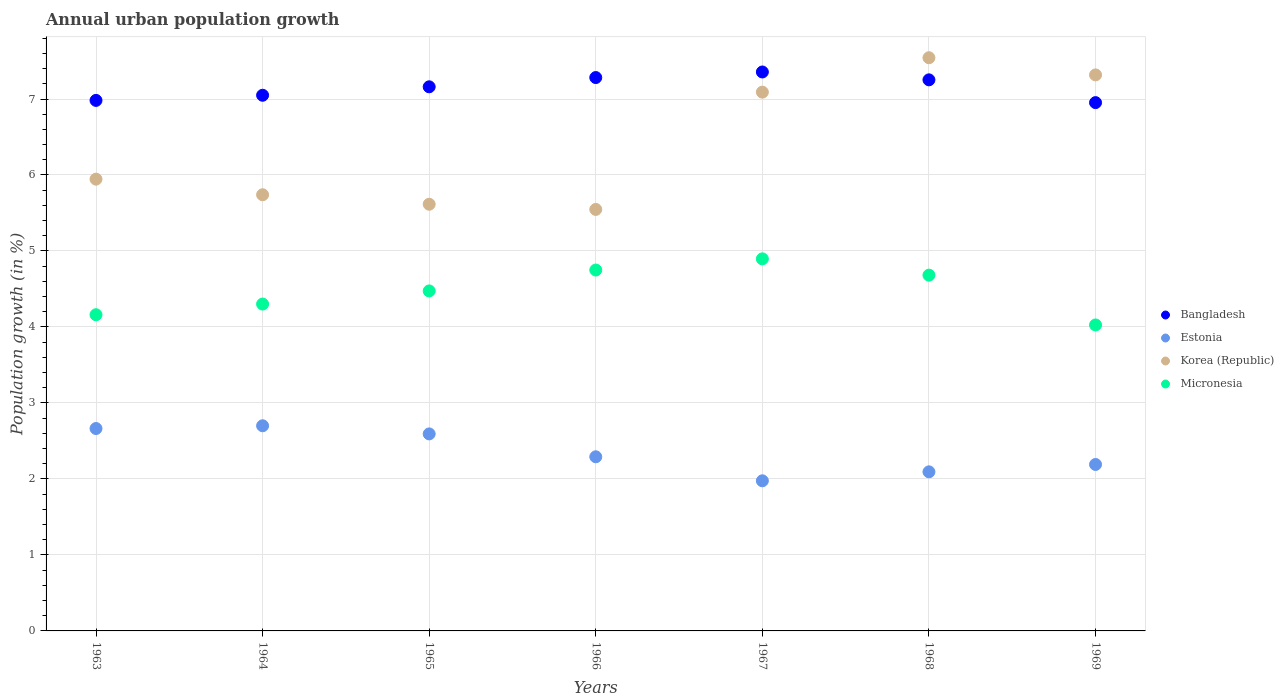How many different coloured dotlines are there?
Ensure brevity in your answer.  4. Is the number of dotlines equal to the number of legend labels?
Provide a succinct answer. Yes. What is the percentage of urban population growth in Korea (Republic) in 1969?
Your answer should be compact. 7.32. Across all years, what is the maximum percentage of urban population growth in Estonia?
Provide a short and direct response. 2.7. Across all years, what is the minimum percentage of urban population growth in Micronesia?
Offer a very short reply. 4.03. In which year was the percentage of urban population growth in Bangladesh maximum?
Offer a terse response. 1967. In which year was the percentage of urban population growth in Bangladesh minimum?
Offer a terse response. 1969. What is the total percentage of urban population growth in Micronesia in the graph?
Offer a terse response. 31.29. What is the difference between the percentage of urban population growth in Bangladesh in 1964 and that in 1969?
Provide a short and direct response. 0.1. What is the difference between the percentage of urban population growth in Micronesia in 1967 and the percentage of urban population growth in Estonia in 1965?
Offer a very short reply. 2.3. What is the average percentage of urban population growth in Micronesia per year?
Keep it short and to the point. 4.47. In the year 1966, what is the difference between the percentage of urban population growth in Korea (Republic) and percentage of urban population growth in Micronesia?
Your answer should be compact. 0.8. What is the ratio of the percentage of urban population growth in Micronesia in 1965 to that in 1967?
Offer a terse response. 0.91. Is the percentage of urban population growth in Micronesia in 1963 less than that in 1969?
Offer a terse response. No. Is the difference between the percentage of urban population growth in Korea (Republic) in 1964 and 1969 greater than the difference between the percentage of urban population growth in Micronesia in 1964 and 1969?
Make the answer very short. No. What is the difference between the highest and the second highest percentage of urban population growth in Estonia?
Provide a succinct answer. 0.04. What is the difference between the highest and the lowest percentage of urban population growth in Bangladesh?
Offer a terse response. 0.4. Is the sum of the percentage of urban population growth in Bangladesh in 1963 and 1967 greater than the maximum percentage of urban population growth in Korea (Republic) across all years?
Give a very brief answer. Yes. Is it the case that in every year, the sum of the percentage of urban population growth in Estonia and percentage of urban population growth in Bangladesh  is greater than the sum of percentage of urban population growth in Korea (Republic) and percentage of urban population growth in Micronesia?
Your answer should be compact. Yes. Is it the case that in every year, the sum of the percentage of urban population growth in Bangladesh and percentage of urban population growth in Micronesia  is greater than the percentage of urban population growth in Estonia?
Provide a short and direct response. Yes. Is the percentage of urban population growth in Estonia strictly greater than the percentage of urban population growth in Bangladesh over the years?
Give a very brief answer. No. What is the difference between two consecutive major ticks on the Y-axis?
Offer a very short reply. 1. Does the graph contain any zero values?
Provide a succinct answer. No. Does the graph contain grids?
Offer a very short reply. Yes. Where does the legend appear in the graph?
Provide a short and direct response. Center right. How many legend labels are there?
Your answer should be very brief. 4. What is the title of the graph?
Ensure brevity in your answer.  Annual urban population growth. Does "Haiti" appear as one of the legend labels in the graph?
Make the answer very short. No. What is the label or title of the X-axis?
Give a very brief answer. Years. What is the label or title of the Y-axis?
Offer a terse response. Population growth (in %). What is the Population growth (in %) of Bangladesh in 1963?
Provide a short and direct response. 6.98. What is the Population growth (in %) of Estonia in 1963?
Provide a succinct answer. 2.66. What is the Population growth (in %) in Korea (Republic) in 1963?
Ensure brevity in your answer.  5.95. What is the Population growth (in %) in Micronesia in 1963?
Your answer should be very brief. 4.16. What is the Population growth (in %) of Bangladesh in 1964?
Make the answer very short. 7.05. What is the Population growth (in %) in Estonia in 1964?
Give a very brief answer. 2.7. What is the Population growth (in %) of Korea (Republic) in 1964?
Keep it short and to the point. 5.74. What is the Population growth (in %) of Micronesia in 1964?
Your answer should be very brief. 4.3. What is the Population growth (in %) in Bangladesh in 1965?
Your answer should be compact. 7.16. What is the Population growth (in %) in Estonia in 1965?
Your response must be concise. 2.59. What is the Population growth (in %) in Korea (Republic) in 1965?
Your response must be concise. 5.62. What is the Population growth (in %) of Micronesia in 1965?
Ensure brevity in your answer.  4.47. What is the Population growth (in %) in Bangladesh in 1966?
Provide a short and direct response. 7.28. What is the Population growth (in %) of Estonia in 1966?
Your response must be concise. 2.29. What is the Population growth (in %) in Korea (Republic) in 1966?
Provide a short and direct response. 5.55. What is the Population growth (in %) of Micronesia in 1966?
Provide a succinct answer. 4.75. What is the Population growth (in %) of Bangladesh in 1967?
Your answer should be compact. 7.36. What is the Population growth (in %) in Estonia in 1967?
Your answer should be very brief. 1.98. What is the Population growth (in %) of Korea (Republic) in 1967?
Offer a terse response. 7.09. What is the Population growth (in %) of Micronesia in 1967?
Your answer should be very brief. 4.9. What is the Population growth (in %) of Bangladesh in 1968?
Ensure brevity in your answer.  7.25. What is the Population growth (in %) in Estonia in 1968?
Offer a terse response. 2.09. What is the Population growth (in %) in Korea (Republic) in 1968?
Ensure brevity in your answer.  7.54. What is the Population growth (in %) in Micronesia in 1968?
Make the answer very short. 4.68. What is the Population growth (in %) of Bangladesh in 1969?
Offer a terse response. 6.95. What is the Population growth (in %) in Estonia in 1969?
Your answer should be very brief. 2.19. What is the Population growth (in %) in Korea (Republic) in 1969?
Ensure brevity in your answer.  7.32. What is the Population growth (in %) of Micronesia in 1969?
Offer a very short reply. 4.03. Across all years, what is the maximum Population growth (in %) of Bangladesh?
Offer a very short reply. 7.36. Across all years, what is the maximum Population growth (in %) in Estonia?
Make the answer very short. 2.7. Across all years, what is the maximum Population growth (in %) in Korea (Republic)?
Give a very brief answer. 7.54. Across all years, what is the maximum Population growth (in %) of Micronesia?
Your answer should be very brief. 4.9. Across all years, what is the minimum Population growth (in %) in Bangladesh?
Provide a succinct answer. 6.95. Across all years, what is the minimum Population growth (in %) in Estonia?
Provide a succinct answer. 1.98. Across all years, what is the minimum Population growth (in %) of Korea (Republic)?
Provide a succinct answer. 5.55. Across all years, what is the minimum Population growth (in %) in Micronesia?
Provide a short and direct response. 4.03. What is the total Population growth (in %) in Bangladesh in the graph?
Your answer should be very brief. 50.03. What is the total Population growth (in %) of Estonia in the graph?
Your answer should be compact. 16.51. What is the total Population growth (in %) in Korea (Republic) in the graph?
Your answer should be compact. 44.8. What is the total Population growth (in %) of Micronesia in the graph?
Make the answer very short. 31.29. What is the difference between the Population growth (in %) in Bangladesh in 1963 and that in 1964?
Your response must be concise. -0.07. What is the difference between the Population growth (in %) of Estonia in 1963 and that in 1964?
Ensure brevity in your answer.  -0.04. What is the difference between the Population growth (in %) in Korea (Republic) in 1963 and that in 1964?
Provide a short and direct response. 0.21. What is the difference between the Population growth (in %) of Micronesia in 1963 and that in 1964?
Ensure brevity in your answer.  -0.14. What is the difference between the Population growth (in %) in Bangladesh in 1963 and that in 1965?
Your answer should be very brief. -0.18. What is the difference between the Population growth (in %) of Estonia in 1963 and that in 1965?
Ensure brevity in your answer.  0.07. What is the difference between the Population growth (in %) in Korea (Republic) in 1963 and that in 1965?
Make the answer very short. 0.33. What is the difference between the Population growth (in %) in Micronesia in 1963 and that in 1965?
Keep it short and to the point. -0.31. What is the difference between the Population growth (in %) in Bangladesh in 1963 and that in 1966?
Offer a terse response. -0.3. What is the difference between the Population growth (in %) in Estonia in 1963 and that in 1966?
Give a very brief answer. 0.37. What is the difference between the Population growth (in %) of Korea (Republic) in 1963 and that in 1966?
Provide a succinct answer. 0.4. What is the difference between the Population growth (in %) in Micronesia in 1963 and that in 1966?
Your response must be concise. -0.59. What is the difference between the Population growth (in %) of Bangladesh in 1963 and that in 1967?
Keep it short and to the point. -0.37. What is the difference between the Population growth (in %) of Estonia in 1963 and that in 1967?
Offer a very short reply. 0.69. What is the difference between the Population growth (in %) of Korea (Republic) in 1963 and that in 1967?
Ensure brevity in your answer.  -1.14. What is the difference between the Population growth (in %) of Micronesia in 1963 and that in 1967?
Your answer should be compact. -0.74. What is the difference between the Population growth (in %) in Bangladesh in 1963 and that in 1968?
Ensure brevity in your answer.  -0.27. What is the difference between the Population growth (in %) in Estonia in 1963 and that in 1968?
Keep it short and to the point. 0.57. What is the difference between the Population growth (in %) of Korea (Republic) in 1963 and that in 1968?
Your response must be concise. -1.6. What is the difference between the Population growth (in %) in Micronesia in 1963 and that in 1968?
Your answer should be very brief. -0.52. What is the difference between the Population growth (in %) of Bangladesh in 1963 and that in 1969?
Give a very brief answer. 0.03. What is the difference between the Population growth (in %) of Estonia in 1963 and that in 1969?
Give a very brief answer. 0.47. What is the difference between the Population growth (in %) in Korea (Republic) in 1963 and that in 1969?
Provide a short and direct response. -1.37. What is the difference between the Population growth (in %) of Micronesia in 1963 and that in 1969?
Your response must be concise. 0.13. What is the difference between the Population growth (in %) of Bangladesh in 1964 and that in 1965?
Keep it short and to the point. -0.11. What is the difference between the Population growth (in %) of Estonia in 1964 and that in 1965?
Your response must be concise. 0.11. What is the difference between the Population growth (in %) in Korea (Republic) in 1964 and that in 1965?
Offer a terse response. 0.12. What is the difference between the Population growth (in %) of Micronesia in 1964 and that in 1965?
Provide a succinct answer. -0.17. What is the difference between the Population growth (in %) in Bangladesh in 1964 and that in 1966?
Offer a very short reply. -0.23. What is the difference between the Population growth (in %) of Estonia in 1964 and that in 1966?
Your response must be concise. 0.41. What is the difference between the Population growth (in %) in Korea (Republic) in 1964 and that in 1966?
Provide a short and direct response. 0.19. What is the difference between the Population growth (in %) of Micronesia in 1964 and that in 1966?
Your answer should be very brief. -0.45. What is the difference between the Population growth (in %) of Bangladesh in 1964 and that in 1967?
Make the answer very short. -0.31. What is the difference between the Population growth (in %) in Estonia in 1964 and that in 1967?
Keep it short and to the point. 0.72. What is the difference between the Population growth (in %) of Korea (Republic) in 1964 and that in 1967?
Your answer should be very brief. -1.35. What is the difference between the Population growth (in %) in Micronesia in 1964 and that in 1967?
Your answer should be compact. -0.59. What is the difference between the Population growth (in %) of Bangladesh in 1964 and that in 1968?
Make the answer very short. -0.2. What is the difference between the Population growth (in %) of Estonia in 1964 and that in 1968?
Keep it short and to the point. 0.61. What is the difference between the Population growth (in %) of Korea (Republic) in 1964 and that in 1968?
Offer a very short reply. -1.8. What is the difference between the Population growth (in %) of Micronesia in 1964 and that in 1968?
Ensure brevity in your answer.  -0.38. What is the difference between the Population growth (in %) in Bangladesh in 1964 and that in 1969?
Your response must be concise. 0.1. What is the difference between the Population growth (in %) of Estonia in 1964 and that in 1969?
Your answer should be compact. 0.51. What is the difference between the Population growth (in %) of Korea (Republic) in 1964 and that in 1969?
Your answer should be very brief. -1.58. What is the difference between the Population growth (in %) of Micronesia in 1964 and that in 1969?
Your response must be concise. 0.27. What is the difference between the Population growth (in %) of Bangladesh in 1965 and that in 1966?
Provide a short and direct response. -0.12. What is the difference between the Population growth (in %) in Estonia in 1965 and that in 1966?
Your response must be concise. 0.3. What is the difference between the Population growth (in %) of Korea (Republic) in 1965 and that in 1966?
Offer a very short reply. 0.07. What is the difference between the Population growth (in %) of Micronesia in 1965 and that in 1966?
Ensure brevity in your answer.  -0.27. What is the difference between the Population growth (in %) in Bangladesh in 1965 and that in 1967?
Your answer should be very brief. -0.2. What is the difference between the Population growth (in %) in Estonia in 1965 and that in 1967?
Provide a short and direct response. 0.62. What is the difference between the Population growth (in %) in Korea (Republic) in 1965 and that in 1967?
Ensure brevity in your answer.  -1.48. What is the difference between the Population growth (in %) in Micronesia in 1965 and that in 1967?
Make the answer very short. -0.42. What is the difference between the Population growth (in %) in Bangladesh in 1965 and that in 1968?
Offer a terse response. -0.09. What is the difference between the Population growth (in %) of Estonia in 1965 and that in 1968?
Provide a succinct answer. 0.5. What is the difference between the Population growth (in %) in Korea (Republic) in 1965 and that in 1968?
Provide a succinct answer. -1.93. What is the difference between the Population growth (in %) in Micronesia in 1965 and that in 1968?
Give a very brief answer. -0.21. What is the difference between the Population growth (in %) of Bangladesh in 1965 and that in 1969?
Give a very brief answer. 0.21. What is the difference between the Population growth (in %) of Estonia in 1965 and that in 1969?
Your answer should be compact. 0.4. What is the difference between the Population growth (in %) of Korea (Republic) in 1965 and that in 1969?
Make the answer very short. -1.7. What is the difference between the Population growth (in %) of Micronesia in 1965 and that in 1969?
Your answer should be compact. 0.45. What is the difference between the Population growth (in %) of Bangladesh in 1966 and that in 1967?
Keep it short and to the point. -0.07. What is the difference between the Population growth (in %) in Estonia in 1966 and that in 1967?
Offer a very short reply. 0.32. What is the difference between the Population growth (in %) of Korea (Republic) in 1966 and that in 1967?
Give a very brief answer. -1.54. What is the difference between the Population growth (in %) in Micronesia in 1966 and that in 1967?
Your answer should be very brief. -0.15. What is the difference between the Population growth (in %) in Bangladesh in 1966 and that in 1968?
Your response must be concise. 0.03. What is the difference between the Population growth (in %) in Estonia in 1966 and that in 1968?
Offer a terse response. 0.2. What is the difference between the Population growth (in %) of Korea (Republic) in 1966 and that in 1968?
Provide a short and direct response. -2. What is the difference between the Population growth (in %) of Micronesia in 1966 and that in 1968?
Give a very brief answer. 0.07. What is the difference between the Population growth (in %) of Bangladesh in 1966 and that in 1969?
Keep it short and to the point. 0.33. What is the difference between the Population growth (in %) in Estonia in 1966 and that in 1969?
Make the answer very short. 0.1. What is the difference between the Population growth (in %) in Korea (Republic) in 1966 and that in 1969?
Make the answer very short. -1.77. What is the difference between the Population growth (in %) of Micronesia in 1966 and that in 1969?
Your answer should be very brief. 0.72. What is the difference between the Population growth (in %) of Bangladesh in 1967 and that in 1968?
Your response must be concise. 0.1. What is the difference between the Population growth (in %) of Estonia in 1967 and that in 1968?
Ensure brevity in your answer.  -0.12. What is the difference between the Population growth (in %) of Korea (Republic) in 1967 and that in 1968?
Offer a very short reply. -0.45. What is the difference between the Population growth (in %) of Micronesia in 1967 and that in 1968?
Provide a short and direct response. 0.21. What is the difference between the Population growth (in %) of Bangladesh in 1967 and that in 1969?
Provide a short and direct response. 0.4. What is the difference between the Population growth (in %) of Estonia in 1967 and that in 1969?
Give a very brief answer. -0.21. What is the difference between the Population growth (in %) in Korea (Republic) in 1967 and that in 1969?
Ensure brevity in your answer.  -0.23. What is the difference between the Population growth (in %) of Micronesia in 1967 and that in 1969?
Provide a short and direct response. 0.87. What is the difference between the Population growth (in %) in Bangladesh in 1968 and that in 1969?
Make the answer very short. 0.3. What is the difference between the Population growth (in %) of Estonia in 1968 and that in 1969?
Keep it short and to the point. -0.1. What is the difference between the Population growth (in %) of Korea (Republic) in 1968 and that in 1969?
Provide a short and direct response. 0.23. What is the difference between the Population growth (in %) of Micronesia in 1968 and that in 1969?
Your response must be concise. 0.66. What is the difference between the Population growth (in %) of Bangladesh in 1963 and the Population growth (in %) of Estonia in 1964?
Offer a terse response. 4.28. What is the difference between the Population growth (in %) of Bangladesh in 1963 and the Population growth (in %) of Korea (Republic) in 1964?
Your answer should be compact. 1.24. What is the difference between the Population growth (in %) of Bangladesh in 1963 and the Population growth (in %) of Micronesia in 1964?
Ensure brevity in your answer.  2.68. What is the difference between the Population growth (in %) in Estonia in 1963 and the Population growth (in %) in Korea (Republic) in 1964?
Keep it short and to the point. -3.08. What is the difference between the Population growth (in %) in Estonia in 1963 and the Population growth (in %) in Micronesia in 1964?
Your response must be concise. -1.64. What is the difference between the Population growth (in %) of Korea (Republic) in 1963 and the Population growth (in %) of Micronesia in 1964?
Offer a very short reply. 1.64. What is the difference between the Population growth (in %) in Bangladesh in 1963 and the Population growth (in %) in Estonia in 1965?
Keep it short and to the point. 4.39. What is the difference between the Population growth (in %) of Bangladesh in 1963 and the Population growth (in %) of Korea (Republic) in 1965?
Offer a terse response. 1.37. What is the difference between the Population growth (in %) of Bangladesh in 1963 and the Population growth (in %) of Micronesia in 1965?
Your answer should be very brief. 2.51. What is the difference between the Population growth (in %) of Estonia in 1963 and the Population growth (in %) of Korea (Republic) in 1965?
Provide a succinct answer. -2.95. What is the difference between the Population growth (in %) of Estonia in 1963 and the Population growth (in %) of Micronesia in 1965?
Your response must be concise. -1.81. What is the difference between the Population growth (in %) in Korea (Republic) in 1963 and the Population growth (in %) in Micronesia in 1965?
Make the answer very short. 1.47. What is the difference between the Population growth (in %) in Bangladesh in 1963 and the Population growth (in %) in Estonia in 1966?
Keep it short and to the point. 4.69. What is the difference between the Population growth (in %) of Bangladesh in 1963 and the Population growth (in %) of Korea (Republic) in 1966?
Offer a terse response. 1.43. What is the difference between the Population growth (in %) of Bangladesh in 1963 and the Population growth (in %) of Micronesia in 1966?
Your answer should be very brief. 2.23. What is the difference between the Population growth (in %) in Estonia in 1963 and the Population growth (in %) in Korea (Republic) in 1966?
Offer a terse response. -2.88. What is the difference between the Population growth (in %) of Estonia in 1963 and the Population growth (in %) of Micronesia in 1966?
Provide a short and direct response. -2.09. What is the difference between the Population growth (in %) in Korea (Republic) in 1963 and the Population growth (in %) in Micronesia in 1966?
Keep it short and to the point. 1.2. What is the difference between the Population growth (in %) of Bangladesh in 1963 and the Population growth (in %) of Estonia in 1967?
Your answer should be very brief. 5.01. What is the difference between the Population growth (in %) in Bangladesh in 1963 and the Population growth (in %) in Korea (Republic) in 1967?
Your response must be concise. -0.11. What is the difference between the Population growth (in %) in Bangladesh in 1963 and the Population growth (in %) in Micronesia in 1967?
Provide a succinct answer. 2.09. What is the difference between the Population growth (in %) in Estonia in 1963 and the Population growth (in %) in Korea (Republic) in 1967?
Your answer should be compact. -4.43. What is the difference between the Population growth (in %) in Estonia in 1963 and the Population growth (in %) in Micronesia in 1967?
Your response must be concise. -2.23. What is the difference between the Population growth (in %) in Korea (Republic) in 1963 and the Population growth (in %) in Micronesia in 1967?
Your answer should be compact. 1.05. What is the difference between the Population growth (in %) of Bangladesh in 1963 and the Population growth (in %) of Estonia in 1968?
Keep it short and to the point. 4.89. What is the difference between the Population growth (in %) of Bangladesh in 1963 and the Population growth (in %) of Korea (Republic) in 1968?
Offer a terse response. -0.56. What is the difference between the Population growth (in %) in Bangladesh in 1963 and the Population growth (in %) in Micronesia in 1968?
Give a very brief answer. 2.3. What is the difference between the Population growth (in %) of Estonia in 1963 and the Population growth (in %) of Korea (Republic) in 1968?
Ensure brevity in your answer.  -4.88. What is the difference between the Population growth (in %) of Estonia in 1963 and the Population growth (in %) of Micronesia in 1968?
Your answer should be very brief. -2.02. What is the difference between the Population growth (in %) of Korea (Republic) in 1963 and the Population growth (in %) of Micronesia in 1968?
Your answer should be very brief. 1.26. What is the difference between the Population growth (in %) in Bangladesh in 1963 and the Population growth (in %) in Estonia in 1969?
Make the answer very short. 4.79. What is the difference between the Population growth (in %) in Bangladesh in 1963 and the Population growth (in %) in Korea (Republic) in 1969?
Provide a succinct answer. -0.34. What is the difference between the Population growth (in %) in Bangladesh in 1963 and the Population growth (in %) in Micronesia in 1969?
Provide a succinct answer. 2.95. What is the difference between the Population growth (in %) of Estonia in 1963 and the Population growth (in %) of Korea (Republic) in 1969?
Your response must be concise. -4.65. What is the difference between the Population growth (in %) of Estonia in 1963 and the Population growth (in %) of Micronesia in 1969?
Your answer should be very brief. -1.36. What is the difference between the Population growth (in %) in Korea (Republic) in 1963 and the Population growth (in %) in Micronesia in 1969?
Your response must be concise. 1.92. What is the difference between the Population growth (in %) in Bangladesh in 1964 and the Population growth (in %) in Estonia in 1965?
Give a very brief answer. 4.46. What is the difference between the Population growth (in %) in Bangladesh in 1964 and the Population growth (in %) in Korea (Republic) in 1965?
Keep it short and to the point. 1.43. What is the difference between the Population growth (in %) in Bangladesh in 1964 and the Population growth (in %) in Micronesia in 1965?
Your answer should be compact. 2.57. What is the difference between the Population growth (in %) in Estonia in 1964 and the Population growth (in %) in Korea (Republic) in 1965?
Provide a short and direct response. -2.92. What is the difference between the Population growth (in %) in Estonia in 1964 and the Population growth (in %) in Micronesia in 1965?
Offer a terse response. -1.77. What is the difference between the Population growth (in %) in Korea (Republic) in 1964 and the Population growth (in %) in Micronesia in 1965?
Provide a short and direct response. 1.27. What is the difference between the Population growth (in %) of Bangladesh in 1964 and the Population growth (in %) of Estonia in 1966?
Offer a very short reply. 4.76. What is the difference between the Population growth (in %) in Bangladesh in 1964 and the Population growth (in %) in Korea (Republic) in 1966?
Ensure brevity in your answer.  1.5. What is the difference between the Population growth (in %) of Bangladesh in 1964 and the Population growth (in %) of Micronesia in 1966?
Ensure brevity in your answer.  2.3. What is the difference between the Population growth (in %) of Estonia in 1964 and the Population growth (in %) of Korea (Republic) in 1966?
Offer a very short reply. -2.85. What is the difference between the Population growth (in %) in Estonia in 1964 and the Population growth (in %) in Micronesia in 1966?
Ensure brevity in your answer.  -2.05. What is the difference between the Population growth (in %) in Korea (Republic) in 1964 and the Population growth (in %) in Micronesia in 1966?
Offer a very short reply. 0.99. What is the difference between the Population growth (in %) in Bangladesh in 1964 and the Population growth (in %) in Estonia in 1967?
Offer a very short reply. 5.07. What is the difference between the Population growth (in %) in Bangladesh in 1964 and the Population growth (in %) in Korea (Republic) in 1967?
Make the answer very short. -0.04. What is the difference between the Population growth (in %) in Bangladesh in 1964 and the Population growth (in %) in Micronesia in 1967?
Keep it short and to the point. 2.15. What is the difference between the Population growth (in %) of Estonia in 1964 and the Population growth (in %) of Korea (Republic) in 1967?
Give a very brief answer. -4.39. What is the difference between the Population growth (in %) of Estonia in 1964 and the Population growth (in %) of Micronesia in 1967?
Provide a short and direct response. -2.2. What is the difference between the Population growth (in %) in Korea (Republic) in 1964 and the Population growth (in %) in Micronesia in 1967?
Give a very brief answer. 0.84. What is the difference between the Population growth (in %) in Bangladesh in 1964 and the Population growth (in %) in Estonia in 1968?
Ensure brevity in your answer.  4.96. What is the difference between the Population growth (in %) in Bangladesh in 1964 and the Population growth (in %) in Korea (Republic) in 1968?
Give a very brief answer. -0.49. What is the difference between the Population growth (in %) in Bangladesh in 1964 and the Population growth (in %) in Micronesia in 1968?
Offer a very short reply. 2.37. What is the difference between the Population growth (in %) in Estonia in 1964 and the Population growth (in %) in Korea (Republic) in 1968?
Your answer should be very brief. -4.84. What is the difference between the Population growth (in %) in Estonia in 1964 and the Population growth (in %) in Micronesia in 1968?
Make the answer very short. -1.98. What is the difference between the Population growth (in %) of Korea (Republic) in 1964 and the Population growth (in %) of Micronesia in 1968?
Provide a short and direct response. 1.06. What is the difference between the Population growth (in %) in Bangladesh in 1964 and the Population growth (in %) in Estonia in 1969?
Offer a terse response. 4.86. What is the difference between the Population growth (in %) in Bangladesh in 1964 and the Population growth (in %) in Korea (Republic) in 1969?
Keep it short and to the point. -0.27. What is the difference between the Population growth (in %) in Bangladesh in 1964 and the Population growth (in %) in Micronesia in 1969?
Provide a short and direct response. 3.02. What is the difference between the Population growth (in %) of Estonia in 1964 and the Population growth (in %) of Korea (Republic) in 1969?
Offer a terse response. -4.62. What is the difference between the Population growth (in %) in Estonia in 1964 and the Population growth (in %) in Micronesia in 1969?
Ensure brevity in your answer.  -1.33. What is the difference between the Population growth (in %) of Korea (Republic) in 1964 and the Population growth (in %) of Micronesia in 1969?
Your answer should be compact. 1.71. What is the difference between the Population growth (in %) in Bangladesh in 1965 and the Population growth (in %) in Estonia in 1966?
Your response must be concise. 4.87. What is the difference between the Population growth (in %) of Bangladesh in 1965 and the Population growth (in %) of Korea (Republic) in 1966?
Ensure brevity in your answer.  1.61. What is the difference between the Population growth (in %) in Bangladesh in 1965 and the Population growth (in %) in Micronesia in 1966?
Your answer should be compact. 2.41. What is the difference between the Population growth (in %) of Estonia in 1965 and the Population growth (in %) of Korea (Republic) in 1966?
Your answer should be very brief. -2.95. What is the difference between the Population growth (in %) of Estonia in 1965 and the Population growth (in %) of Micronesia in 1966?
Your answer should be compact. -2.16. What is the difference between the Population growth (in %) of Korea (Republic) in 1965 and the Population growth (in %) of Micronesia in 1966?
Your response must be concise. 0.87. What is the difference between the Population growth (in %) in Bangladesh in 1965 and the Population growth (in %) in Estonia in 1967?
Ensure brevity in your answer.  5.18. What is the difference between the Population growth (in %) of Bangladesh in 1965 and the Population growth (in %) of Korea (Republic) in 1967?
Keep it short and to the point. 0.07. What is the difference between the Population growth (in %) in Bangladesh in 1965 and the Population growth (in %) in Micronesia in 1967?
Give a very brief answer. 2.26. What is the difference between the Population growth (in %) of Estonia in 1965 and the Population growth (in %) of Korea (Republic) in 1967?
Your answer should be compact. -4.5. What is the difference between the Population growth (in %) of Estonia in 1965 and the Population growth (in %) of Micronesia in 1967?
Make the answer very short. -2.3. What is the difference between the Population growth (in %) in Korea (Republic) in 1965 and the Population growth (in %) in Micronesia in 1967?
Give a very brief answer. 0.72. What is the difference between the Population growth (in %) of Bangladesh in 1965 and the Population growth (in %) of Estonia in 1968?
Provide a succinct answer. 5.07. What is the difference between the Population growth (in %) in Bangladesh in 1965 and the Population growth (in %) in Korea (Republic) in 1968?
Offer a terse response. -0.38. What is the difference between the Population growth (in %) of Bangladesh in 1965 and the Population growth (in %) of Micronesia in 1968?
Offer a terse response. 2.48. What is the difference between the Population growth (in %) in Estonia in 1965 and the Population growth (in %) in Korea (Republic) in 1968?
Keep it short and to the point. -4.95. What is the difference between the Population growth (in %) of Estonia in 1965 and the Population growth (in %) of Micronesia in 1968?
Offer a very short reply. -2.09. What is the difference between the Population growth (in %) of Korea (Republic) in 1965 and the Population growth (in %) of Micronesia in 1968?
Offer a very short reply. 0.93. What is the difference between the Population growth (in %) of Bangladesh in 1965 and the Population growth (in %) of Estonia in 1969?
Offer a very short reply. 4.97. What is the difference between the Population growth (in %) of Bangladesh in 1965 and the Population growth (in %) of Korea (Republic) in 1969?
Keep it short and to the point. -0.16. What is the difference between the Population growth (in %) of Bangladesh in 1965 and the Population growth (in %) of Micronesia in 1969?
Give a very brief answer. 3.13. What is the difference between the Population growth (in %) in Estonia in 1965 and the Population growth (in %) in Korea (Republic) in 1969?
Provide a succinct answer. -4.72. What is the difference between the Population growth (in %) in Estonia in 1965 and the Population growth (in %) in Micronesia in 1969?
Your answer should be very brief. -1.43. What is the difference between the Population growth (in %) of Korea (Republic) in 1965 and the Population growth (in %) of Micronesia in 1969?
Provide a short and direct response. 1.59. What is the difference between the Population growth (in %) of Bangladesh in 1966 and the Population growth (in %) of Estonia in 1967?
Ensure brevity in your answer.  5.31. What is the difference between the Population growth (in %) in Bangladesh in 1966 and the Population growth (in %) in Korea (Republic) in 1967?
Keep it short and to the point. 0.19. What is the difference between the Population growth (in %) of Bangladesh in 1966 and the Population growth (in %) of Micronesia in 1967?
Give a very brief answer. 2.39. What is the difference between the Population growth (in %) of Estonia in 1966 and the Population growth (in %) of Korea (Republic) in 1967?
Your response must be concise. -4.8. What is the difference between the Population growth (in %) of Estonia in 1966 and the Population growth (in %) of Micronesia in 1967?
Your answer should be compact. -2.6. What is the difference between the Population growth (in %) of Korea (Republic) in 1966 and the Population growth (in %) of Micronesia in 1967?
Keep it short and to the point. 0.65. What is the difference between the Population growth (in %) in Bangladesh in 1966 and the Population growth (in %) in Estonia in 1968?
Provide a succinct answer. 5.19. What is the difference between the Population growth (in %) in Bangladesh in 1966 and the Population growth (in %) in Korea (Republic) in 1968?
Your answer should be very brief. -0.26. What is the difference between the Population growth (in %) in Bangladesh in 1966 and the Population growth (in %) in Micronesia in 1968?
Offer a terse response. 2.6. What is the difference between the Population growth (in %) in Estonia in 1966 and the Population growth (in %) in Korea (Republic) in 1968?
Make the answer very short. -5.25. What is the difference between the Population growth (in %) of Estonia in 1966 and the Population growth (in %) of Micronesia in 1968?
Offer a very short reply. -2.39. What is the difference between the Population growth (in %) of Korea (Republic) in 1966 and the Population growth (in %) of Micronesia in 1968?
Your answer should be very brief. 0.86. What is the difference between the Population growth (in %) of Bangladesh in 1966 and the Population growth (in %) of Estonia in 1969?
Make the answer very short. 5.09. What is the difference between the Population growth (in %) in Bangladesh in 1966 and the Population growth (in %) in Korea (Republic) in 1969?
Offer a terse response. -0.04. What is the difference between the Population growth (in %) in Bangladesh in 1966 and the Population growth (in %) in Micronesia in 1969?
Your answer should be compact. 3.26. What is the difference between the Population growth (in %) of Estonia in 1966 and the Population growth (in %) of Korea (Republic) in 1969?
Offer a very short reply. -5.03. What is the difference between the Population growth (in %) of Estonia in 1966 and the Population growth (in %) of Micronesia in 1969?
Provide a succinct answer. -1.74. What is the difference between the Population growth (in %) in Korea (Republic) in 1966 and the Population growth (in %) in Micronesia in 1969?
Your answer should be very brief. 1.52. What is the difference between the Population growth (in %) in Bangladesh in 1967 and the Population growth (in %) in Estonia in 1968?
Provide a succinct answer. 5.26. What is the difference between the Population growth (in %) of Bangladesh in 1967 and the Population growth (in %) of Korea (Republic) in 1968?
Your answer should be very brief. -0.19. What is the difference between the Population growth (in %) of Bangladesh in 1967 and the Population growth (in %) of Micronesia in 1968?
Your answer should be very brief. 2.67. What is the difference between the Population growth (in %) of Estonia in 1967 and the Population growth (in %) of Korea (Republic) in 1968?
Offer a terse response. -5.57. What is the difference between the Population growth (in %) of Estonia in 1967 and the Population growth (in %) of Micronesia in 1968?
Make the answer very short. -2.71. What is the difference between the Population growth (in %) of Korea (Republic) in 1967 and the Population growth (in %) of Micronesia in 1968?
Your answer should be very brief. 2.41. What is the difference between the Population growth (in %) of Bangladesh in 1967 and the Population growth (in %) of Estonia in 1969?
Make the answer very short. 5.17. What is the difference between the Population growth (in %) in Bangladesh in 1967 and the Population growth (in %) in Korea (Republic) in 1969?
Provide a succinct answer. 0.04. What is the difference between the Population growth (in %) in Bangladesh in 1967 and the Population growth (in %) in Micronesia in 1969?
Provide a short and direct response. 3.33. What is the difference between the Population growth (in %) of Estonia in 1967 and the Population growth (in %) of Korea (Republic) in 1969?
Offer a very short reply. -5.34. What is the difference between the Population growth (in %) in Estonia in 1967 and the Population growth (in %) in Micronesia in 1969?
Make the answer very short. -2.05. What is the difference between the Population growth (in %) in Korea (Republic) in 1967 and the Population growth (in %) in Micronesia in 1969?
Your answer should be very brief. 3.06. What is the difference between the Population growth (in %) in Bangladesh in 1968 and the Population growth (in %) in Estonia in 1969?
Provide a short and direct response. 5.06. What is the difference between the Population growth (in %) of Bangladesh in 1968 and the Population growth (in %) of Korea (Republic) in 1969?
Offer a terse response. -0.07. What is the difference between the Population growth (in %) in Bangladesh in 1968 and the Population growth (in %) in Micronesia in 1969?
Provide a succinct answer. 3.23. What is the difference between the Population growth (in %) of Estonia in 1968 and the Population growth (in %) of Korea (Republic) in 1969?
Your answer should be very brief. -5.22. What is the difference between the Population growth (in %) of Estonia in 1968 and the Population growth (in %) of Micronesia in 1969?
Your answer should be very brief. -1.93. What is the difference between the Population growth (in %) of Korea (Republic) in 1968 and the Population growth (in %) of Micronesia in 1969?
Provide a succinct answer. 3.52. What is the average Population growth (in %) of Bangladesh per year?
Ensure brevity in your answer.  7.15. What is the average Population growth (in %) in Estonia per year?
Your answer should be compact. 2.36. What is the average Population growth (in %) in Korea (Republic) per year?
Offer a terse response. 6.4. What is the average Population growth (in %) in Micronesia per year?
Make the answer very short. 4.47. In the year 1963, what is the difference between the Population growth (in %) in Bangladesh and Population growth (in %) in Estonia?
Offer a very short reply. 4.32. In the year 1963, what is the difference between the Population growth (in %) in Bangladesh and Population growth (in %) in Korea (Republic)?
Your response must be concise. 1.04. In the year 1963, what is the difference between the Population growth (in %) in Bangladesh and Population growth (in %) in Micronesia?
Give a very brief answer. 2.82. In the year 1963, what is the difference between the Population growth (in %) in Estonia and Population growth (in %) in Korea (Republic)?
Provide a short and direct response. -3.28. In the year 1963, what is the difference between the Population growth (in %) in Estonia and Population growth (in %) in Micronesia?
Make the answer very short. -1.5. In the year 1963, what is the difference between the Population growth (in %) in Korea (Republic) and Population growth (in %) in Micronesia?
Provide a short and direct response. 1.78. In the year 1964, what is the difference between the Population growth (in %) in Bangladesh and Population growth (in %) in Estonia?
Offer a very short reply. 4.35. In the year 1964, what is the difference between the Population growth (in %) of Bangladesh and Population growth (in %) of Korea (Republic)?
Offer a very short reply. 1.31. In the year 1964, what is the difference between the Population growth (in %) of Bangladesh and Population growth (in %) of Micronesia?
Give a very brief answer. 2.75. In the year 1964, what is the difference between the Population growth (in %) of Estonia and Population growth (in %) of Korea (Republic)?
Provide a short and direct response. -3.04. In the year 1964, what is the difference between the Population growth (in %) in Estonia and Population growth (in %) in Micronesia?
Your response must be concise. -1.6. In the year 1964, what is the difference between the Population growth (in %) of Korea (Republic) and Population growth (in %) of Micronesia?
Provide a succinct answer. 1.44. In the year 1965, what is the difference between the Population growth (in %) of Bangladesh and Population growth (in %) of Estonia?
Your answer should be very brief. 4.57. In the year 1965, what is the difference between the Population growth (in %) of Bangladesh and Population growth (in %) of Korea (Republic)?
Your response must be concise. 1.55. In the year 1965, what is the difference between the Population growth (in %) in Bangladesh and Population growth (in %) in Micronesia?
Offer a terse response. 2.69. In the year 1965, what is the difference between the Population growth (in %) of Estonia and Population growth (in %) of Korea (Republic)?
Offer a very short reply. -3.02. In the year 1965, what is the difference between the Population growth (in %) in Estonia and Population growth (in %) in Micronesia?
Your response must be concise. -1.88. In the year 1965, what is the difference between the Population growth (in %) of Korea (Republic) and Population growth (in %) of Micronesia?
Provide a short and direct response. 1.14. In the year 1966, what is the difference between the Population growth (in %) in Bangladesh and Population growth (in %) in Estonia?
Provide a succinct answer. 4.99. In the year 1966, what is the difference between the Population growth (in %) in Bangladesh and Population growth (in %) in Korea (Republic)?
Give a very brief answer. 1.74. In the year 1966, what is the difference between the Population growth (in %) of Bangladesh and Population growth (in %) of Micronesia?
Provide a short and direct response. 2.53. In the year 1966, what is the difference between the Population growth (in %) of Estonia and Population growth (in %) of Korea (Republic)?
Your response must be concise. -3.26. In the year 1966, what is the difference between the Population growth (in %) of Estonia and Population growth (in %) of Micronesia?
Offer a very short reply. -2.46. In the year 1966, what is the difference between the Population growth (in %) in Korea (Republic) and Population growth (in %) in Micronesia?
Your response must be concise. 0.8. In the year 1967, what is the difference between the Population growth (in %) in Bangladesh and Population growth (in %) in Estonia?
Your answer should be very brief. 5.38. In the year 1967, what is the difference between the Population growth (in %) in Bangladesh and Population growth (in %) in Korea (Republic)?
Provide a short and direct response. 0.27. In the year 1967, what is the difference between the Population growth (in %) in Bangladesh and Population growth (in %) in Micronesia?
Offer a terse response. 2.46. In the year 1967, what is the difference between the Population growth (in %) in Estonia and Population growth (in %) in Korea (Republic)?
Keep it short and to the point. -5.11. In the year 1967, what is the difference between the Population growth (in %) in Estonia and Population growth (in %) in Micronesia?
Offer a terse response. -2.92. In the year 1967, what is the difference between the Population growth (in %) of Korea (Republic) and Population growth (in %) of Micronesia?
Provide a succinct answer. 2.19. In the year 1968, what is the difference between the Population growth (in %) of Bangladesh and Population growth (in %) of Estonia?
Your answer should be very brief. 5.16. In the year 1968, what is the difference between the Population growth (in %) of Bangladesh and Population growth (in %) of Korea (Republic)?
Offer a terse response. -0.29. In the year 1968, what is the difference between the Population growth (in %) in Bangladesh and Population growth (in %) in Micronesia?
Keep it short and to the point. 2.57. In the year 1968, what is the difference between the Population growth (in %) in Estonia and Population growth (in %) in Korea (Republic)?
Offer a terse response. -5.45. In the year 1968, what is the difference between the Population growth (in %) in Estonia and Population growth (in %) in Micronesia?
Your response must be concise. -2.59. In the year 1968, what is the difference between the Population growth (in %) of Korea (Republic) and Population growth (in %) of Micronesia?
Give a very brief answer. 2.86. In the year 1969, what is the difference between the Population growth (in %) of Bangladesh and Population growth (in %) of Estonia?
Provide a succinct answer. 4.76. In the year 1969, what is the difference between the Population growth (in %) in Bangladesh and Population growth (in %) in Korea (Republic)?
Ensure brevity in your answer.  -0.36. In the year 1969, what is the difference between the Population growth (in %) in Bangladesh and Population growth (in %) in Micronesia?
Provide a succinct answer. 2.93. In the year 1969, what is the difference between the Population growth (in %) of Estonia and Population growth (in %) of Korea (Republic)?
Ensure brevity in your answer.  -5.13. In the year 1969, what is the difference between the Population growth (in %) of Estonia and Population growth (in %) of Micronesia?
Your response must be concise. -1.84. In the year 1969, what is the difference between the Population growth (in %) of Korea (Republic) and Population growth (in %) of Micronesia?
Your answer should be compact. 3.29. What is the ratio of the Population growth (in %) in Bangladesh in 1963 to that in 1964?
Ensure brevity in your answer.  0.99. What is the ratio of the Population growth (in %) of Estonia in 1963 to that in 1964?
Ensure brevity in your answer.  0.99. What is the ratio of the Population growth (in %) in Korea (Republic) in 1963 to that in 1964?
Provide a short and direct response. 1.04. What is the ratio of the Population growth (in %) in Micronesia in 1963 to that in 1964?
Make the answer very short. 0.97. What is the ratio of the Population growth (in %) in Bangladesh in 1963 to that in 1965?
Provide a short and direct response. 0.97. What is the ratio of the Population growth (in %) in Estonia in 1963 to that in 1965?
Ensure brevity in your answer.  1.03. What is the ratio of the Population growth (in %) in Korea (Republic) in 1963 to that in 1965?
Your answer should be compact. 1.06. What is the ratio of the Population growth (in %) in Micronesia in 1963 to that in 1965?
Make the answer very short. 0.93. What is the ratio of the Population growth (in %) of Bangladesh in 1963 to that in 1966?
Give a very brief answer. 0.96. What is the ratio of the Population growth (in %) of Estonia in 1963 to that in 1966?
Ensure brevity in your answer.  1.16. What is the ratio of the Population growth (in %) in Korea (Republic) in 1963 to that in 1966?
Provide a succinct answer. 1.07. What is the ratio of the Population growth (in %) in Micronesia in 1963 to that in 1966?
Your response must be concise. 0.88. What is the ratio of the Population growth (in %) in Bangladesh in 1963 to that in 1967?
Keep it short and to the point. 0.95. What is the ratio of the Population growth (in %) of Estonia in 1963 to that in 1967?
Offer a very short reply. 1.35. What is the ratio of the Population growth (in %) in Korea (Republic) in 1963 to that in 1967?
Ensure brevity in your answer.  0.84. What is the ratio of the Population growth (in %) in Micronesia in 1963 to that in 1967?
Your answer should be compact. 0.85. What is the ratio of the Population growth (in %) of Bangladesh in 1963 to that in 1968?
Ensure brevity in your answer.  0.96. What is the ratio of the Population growth (in %) in Estonia in 1963 to that in 1968?
Offer a terse response. 1.27. What is the ratio of the Population growth (in %) of Korea (Republic) in 1963 to that in 1968?
Provide a succinct answer. 0.79. What is the ratio of the Population growth (in %) in Micronesia in 1963 to that in 1968?
Keep it short and to the point. 0.89. What is the ratio of the Population growth (in %) in Estonia in 1963 to that in 1969?
Give a very brief answer. 1.22. What is the ratio of the Population growth (in %) of Korea (Republic) in 1963 to that in 1969?
Provide a short and direct response. 0.81. What is the ratio of the Population growth (in %) of Micronesia in 1963 to that in 1969?
Ensure brevity in your answer.  1.03. What is the ratio of the Population growth (in %) in Bangladesh in 1964 to that in 1965?
Your response must be concise. 0.98. What is the ratio of the Population growth (in %) in Estonia in 1964 to that in 1965?
Offer a terse response. 1.04. What is the ratio of the Population growth (in %) of Korea (Republic) in 1964 to that in 1965?
Provide a short and direct response. 1.02. What is the ratio of the Population growth (in %) in Micronesia in 1964 to that in 1965?
Make the answer very short. 0.96. What is the ratio of the Population growth (in %) of Bangladesh in 1964 to that in 1966?
Offer a very short reply. 0.97. What is the ratio of the Population growth (in %) in Estonia in 1964 to that in 1966?
Give a very brief answer. 1.18. What is the ratio of the Population growth (in %) of Korea (Republic) in 1964 to that in 1966?
Your answer should be very brief. 1.03. What is the ratio of the Population growth (in %) of Micronesia in 1964 to that in 1966?
Ensure brevity in your answer.  0.91. What is the ratio of the Population growth (in %) in Bangladesh in 1964 to that in 1967?
Ensure brevity in your answer.  0.96. What is the ratio of the Population growth (in %) of Estonia in 1964 to that in 1967?
Keep it short and to the point. 1.37. What is the ratio of the Population growth (in %) of Korea (Republic) in 1964 to that in 1967?
Provide a short and direct response. 0.81. What is the ratio of the Population growth (in %) of Micronesia in 1964 to that in 1967?
Ensure brevity in your answer.  0.88. What is the ratio of the Population growth (in %) of Estonia in 1964 to that in 1968?
Your answer should be compact. 1.29. What is the ratio of the Population growth (in %) of Korea (Republic) in 1964 to that in 1968?
Keep it short and to the point. 0.76. What is the ratio of the Population growth (in %) in Micronesia in 1964 to that in 1968?
Keep it short and to the point. 0.92. What is the ratio of the Population growth (in %) in Bangladesh in 1964 to that in 1969?
Your response must be concise. 1.01. What is the ratio of the Population growth (in %) of Estonia in 1964 to that in 1969?
Make the answer very short. 1.23. What is the ratio of the Population growth (in %) in Korea (Republic) in 1964 to that in 1969?
Your answer should be compact. 0.78. What is the ratio of the Population growth (in %) of Micronesia in 1964 to that in 1969?
Ensure brevity in your answer.  1.07. What is the ratio of the Population growth (in %) in Bangladesh in 1965 to that in 1966?
Offer a very short reply. 0.98. What is the ratio of the Population growth (in %) of Estonia in 1965 to that in 1966?
Offer a terse response. 1.13. What is the ratio of the Population growth (in %) of Korea (Republic) in 1965 to that in 1966?
Offer a terse response. 1.01. What is the ratio of the Population growth (in %) of Micronesia in 1965 to that in 1966?
Give a very brief answer. 0.94. What is the ratio of the Population growth (in %) of Bangladesh in 1965 to that in 1967?
Make the answer very short. 0.97. What is the ratio of the Population growth (in %) of Estonia in 1965 to that in 1967?
Offer a very short reply. 1.31. What is the ratio of the Population growth (in %) in Korea (Republic) in 1965 to that in 1967?
Provide a succinct answer. 0.79. What is the ratio of the Population growth (in %) of Micronesia in 1965 to that in 1967?
Your answer should be compact. 0.91. What is the ratio of the Population growth (in %) in Bangladesh in 1965 to that in 1968?
Your answer should be compact. 0.99. What is the ratio of the Population growth (in %) of Estonia in 1965 to that in 1968?
Provide a succinct answer. 1.24. What is the ratio of the Population growth (in %) in Korea (Republic) in 1965 to that in 1968?
Offer a very short reply. 0.74. What is the ratio of the Population growth (in %) in Micronesia in 1965 to that in 1968?
Make the answer very short. 0.96. What is the ratio of the Population growth (in %) of Bangladesh in 1965 to that in 1969?
Provide a short and direct response. 1.03. What is the ratio of the Population growth (in %) in Estonia in 1965 to that in 1969?
Your response must be concise. 1.18. What is the ratio of the Population growth (in %) of Korea (Republic) in 1965 to that in 1969?
Your answer should be compact. 0.77. What is the ratio of the Population growth (in %) of Micronesia in 1965 to that in 1969?
Your answer should be compact. 1.11. What is the ratio of the Population growth (in %) in Bangladesh in 1966 to that in 1967?
Provide a succinct answer. 0.99. What is the ratio of the Population growth (in %) in Estonia in 1966 to that in 1967?
Provide a short and direct response. 1.16. What is the ratio of the Population growth (in %) in Korea (Republic) in 1966 to that in 1967?
Provide a short and direct response. 0.78. What is the ratio of the Population growth (in %) of Micronesia in 1966 to that in 1967?
Ensure brevity in your answer.  0.97. What is the ratio of the Population growth (in %) of Estonia in 1966 to that in 1968?
Your answer should be compact. 1.09. What is the ratio of the Population growth (in %) in Korea (Republic) in 1966 to that in 1968?
Keep it short and to the point. 0.74. What is the ratio of the Population growth (in %) in Micronesia in 1966 to that in 1968?
Keep it short and to the point. 1.01. What is the ratio of the Population growth (in %) of Bangladesh in 1966 to that in 1969?
Your response must be concise. 1.05. What is the ratio of the Population growth (in %) in Estonia in 1966 to that in 1969?
Your answer should be very brief. 1.05. What is the ratio of the Population growth (in %) of Korea (Republic) in 1966 to that in 1969?
Your response must be concise. 0.76. What is the ratio of the Population growth (in %) of Micronesia in 1966 to that in 1969?
Provide a succinct answer. 1.18. What is the ratio of the Population growth (in %) in Bangladesh in 1967 to that in 1968?
Ensure brevity in your answer.  1.01. What is the ratio of the Population growth (in %) in Estonia in 1967 to that in 1968?
Offer a terse response. 0.94. What is the ratio of the Population growth (in %) in Korea (Republic) in 1967 to that in 1968?
Provide a succinct answer. 0.94. What is the ratio of the Population growth (in %) of Micronesia in 1967 to that in 1968?
Offer a very short reply. 1.05. What is the ratio of the Population growth (in %) of Bangladesh in 1967 to that in 1969?
Keep it short and to the point. 1.06. What is the ratio of the Population growth (in %) of Estonia in 1967 to that in 1969?
Provide a short and direct response. 0.9. What is the ratio of the Population growth (in %) in Korea (Republic) in 1967 to that in 1969?
Your answer should be compact. 0.97. What is the ratio of the Population growth (in %) of Micronesia in 1967 to that in 1969?
Your response must be concise. 1.22. What is the ratio of the Population growth (in %) of Bangladesh in 1968 to that in 1969?
Provide a succinct answer. 1.04. What is the ratio of the Population growth (in %) of Estonia in 1968 to that in 1969?
Provide a succinct answer. 0.96. What is the ratio of the Population growth (in %) of Korea (Republic) in 1968 to that in 1969?
Offer a terse response. 1.03. What is the ratio of the Population growth (in %) in Micronesia in 1968 to that in 1969?
Provide a succinct answer. 1.16. What is the difference between the highest and the second highest Population growth (in %) in Bangladesh?
Make the answer very short. 0.07. What is the difference between the highest and the second highest Population growth (in %) of Estonia?
Provide a short and direct response. 0.04. What is the difference between the highest and the second highest Population growth (in %) in Korea (Republic)?
Ensure brevity in your answer.  0.23. What is the difference between the highest and the second highest Population growth (in %) in Micronesia?
Make the answer very short. 0.15. What is the difference between the highest and the lowest Population growth (in %) in Bangladesh?
Make the answer very short. 0.4. What is the difference between the highest and the lowest Population growth (in %) in Estonia?
Provide a succinct answer. 0.72. What is the difference between the highest and the lowest Population growth (in %) of Korea (Republic)?
Your answer should be very brief. 2. What is the difference between the highest and the lowest Population growth (in %) of Micronesia?
Your answer should be very brief. 0.87. 